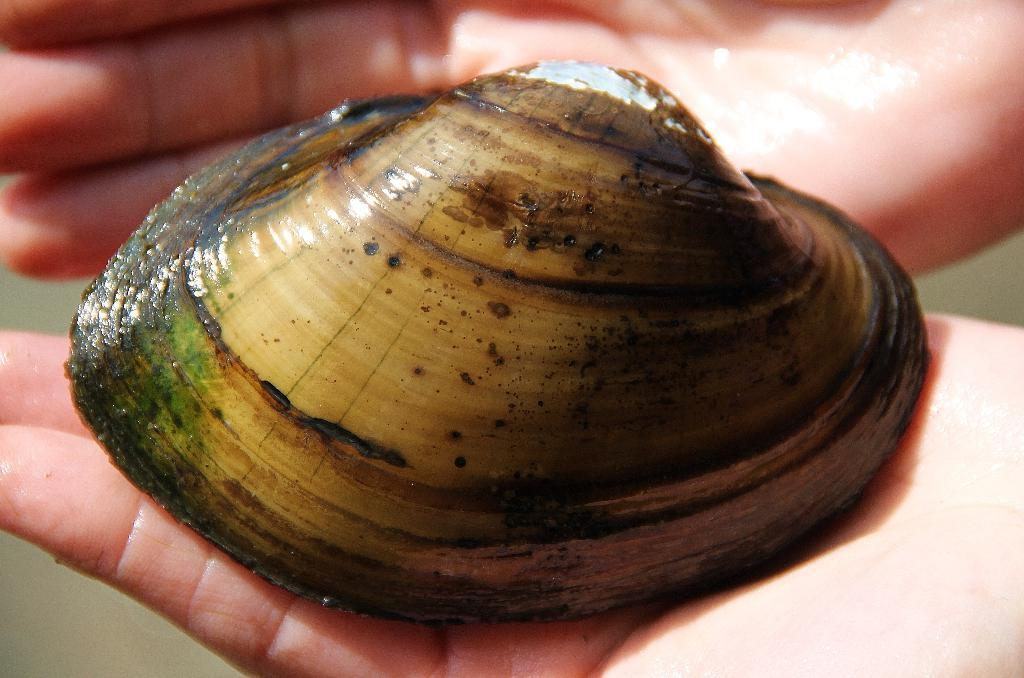What object is the main focus of the image? There is a shell in the image. Can you describe the color of the shell? The shell is in brown and cream color. Who is holding the shell in the image? The shell is being held by a human. What can be observed about the background of the image? The background of the image is completely blurred. What type of cactus can be seen in the background of the image? There is no cactus present in the image; the background is completely blurred. Is the gun visible in the image? There is no gun present in the image; it features a shell being held by a human. 